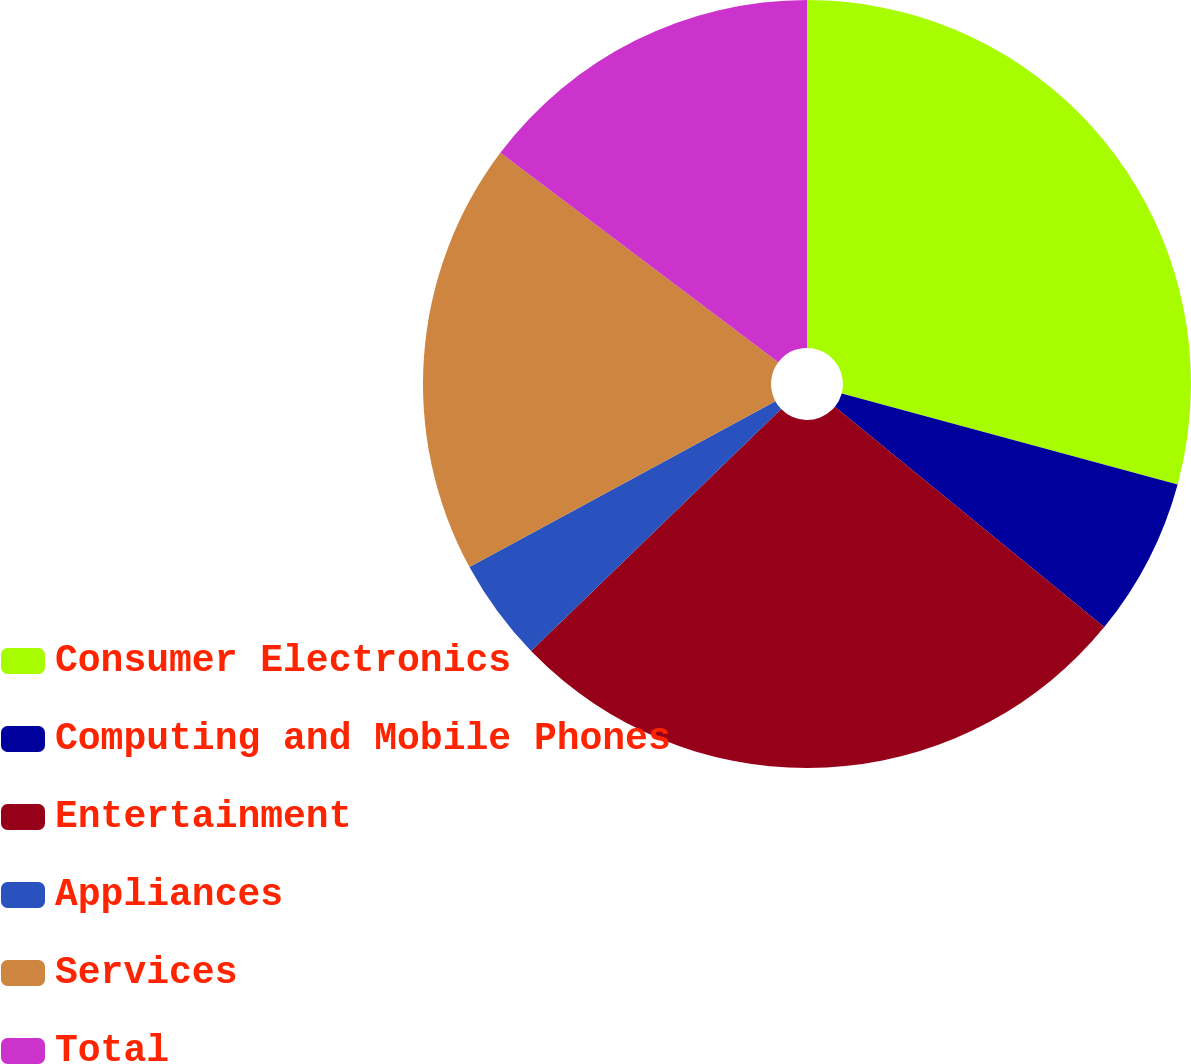Convert chart. <chart><loc_0><loc_0><loc_500><loc_500><pie_chart><fcel>Consumer Electronics<fcel>Computing and Mobile Phones<fcel>Entertainment<fcel>Appliances<fcel>Services<fcel>Total<nl><fcel>29.21%<fcel>6.7%<fcel>26.85%<fcel>4.33%<fcel>18.19%<fcel>14.72%<nl></chart> 